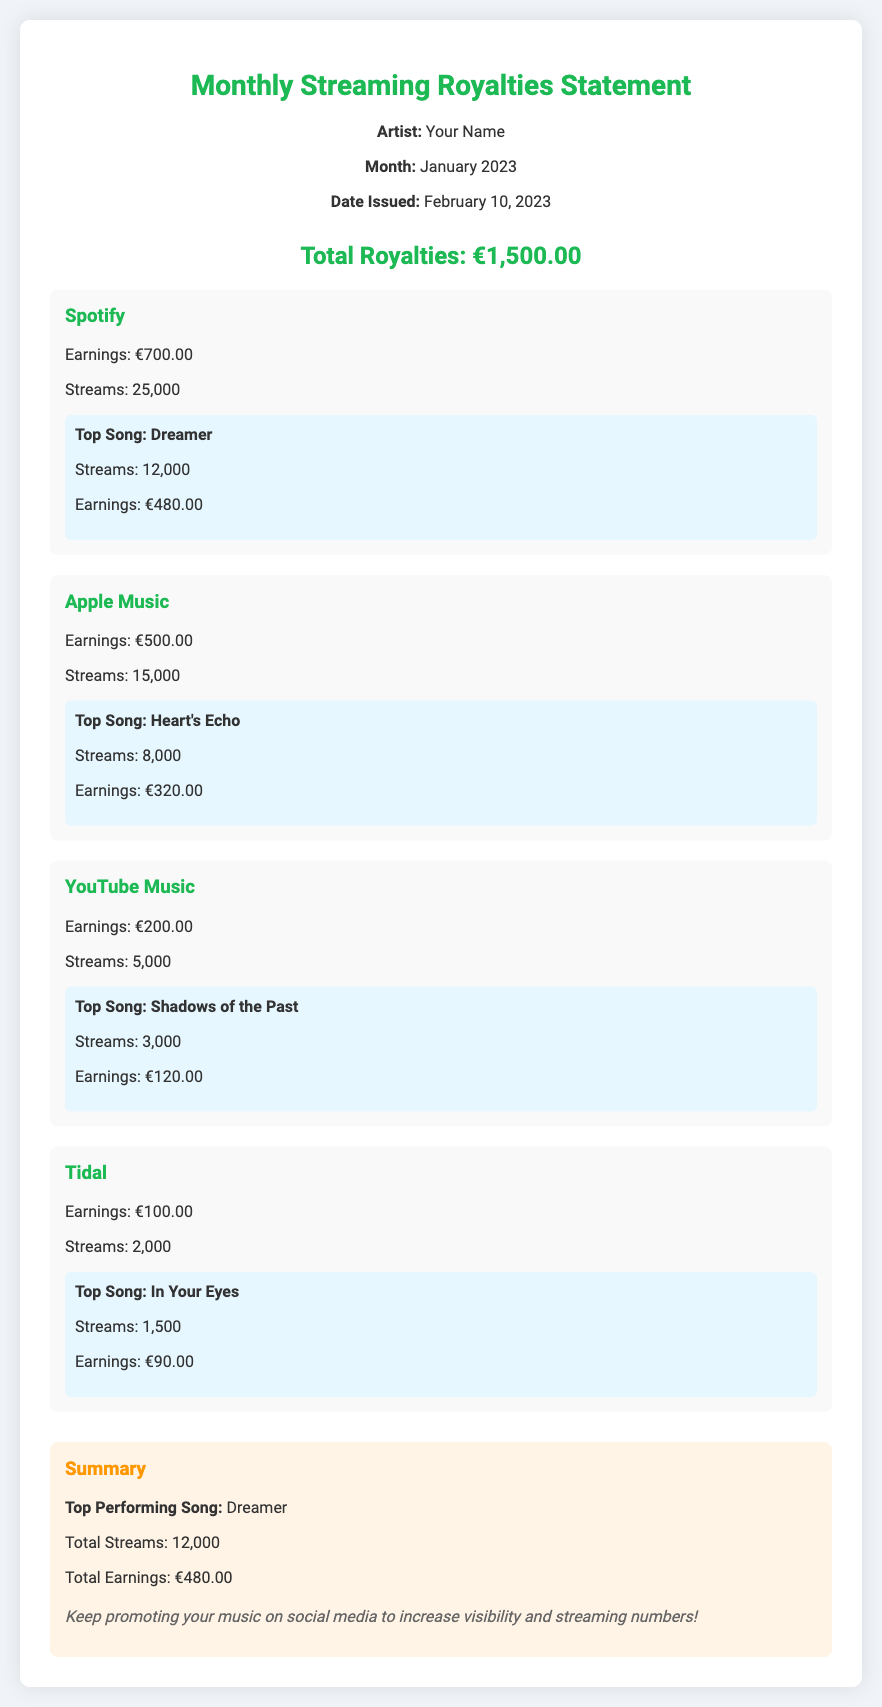What is the total royalties? The total royalties is listed at the top of the document.
Answer: €1,500.00 What platform had the highest earnings? By comparing the earnings of each platform, the highest can be identified.
Answer: Spotify How many streams did "Heart's Echo" receive? The number of streams for each top song is provided in its section.
Answer: 8,000 What is the earnings from YouTube Music? The earnings section for each platform lists individual earnings.
Answer: €200.00 What is the date when the statement was issued? The issue date is explicitly stated in the header section of the document.
Answer: February 10, 2023 Which song was the top performer overall? The summary section highlights the top performing song and its details.
Answer: Dreamer How many total streams did the songs from Spotify generate? The total streams from Spotify are detailed in its section.
Answer: 25,000 What is the total earnings from Tidal? The earnings from Tidal are specified in the platform's section.
Answer: €100.00 What is a noted suggestion to increase streaming numbers? The notes section provides guidance to the artist on promoting their music.
Answer: Keep promoting your music on social media to increase visibility and streaming numbers! 